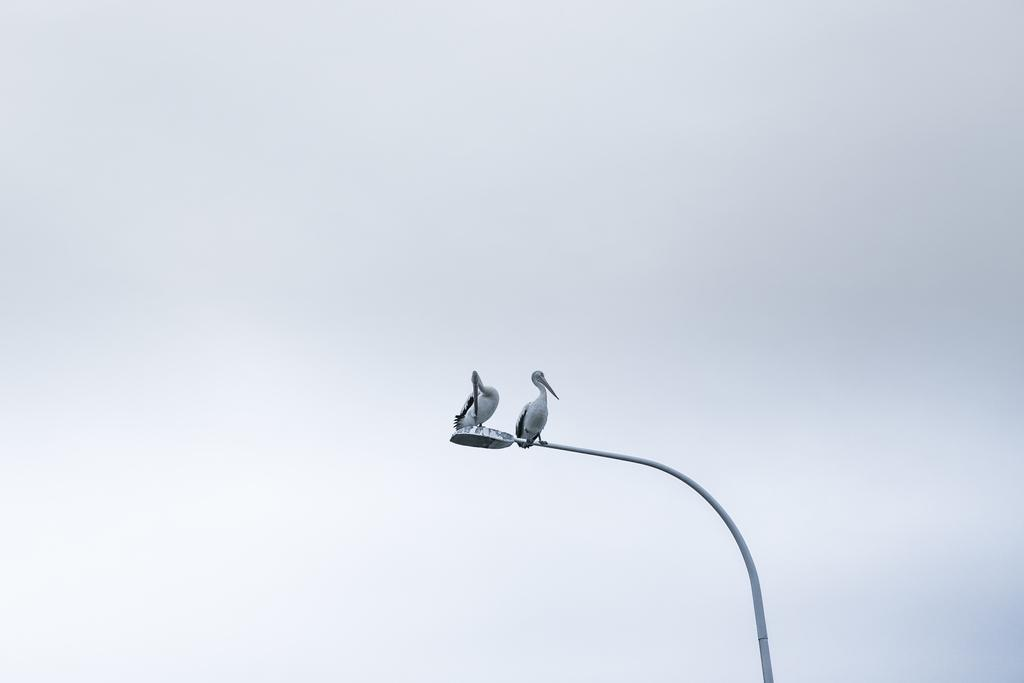How many birds are in the image? There are two birds in the image. Where are the birds located? The birds are sitting on a pole of a street light. What can be seen in the background of the image? There is sky visible in the background of the image. What type of nut is being used to play volleyball in the image? There is no nut or volleyball present in the image; it features two birds sitting on a street light pole. 